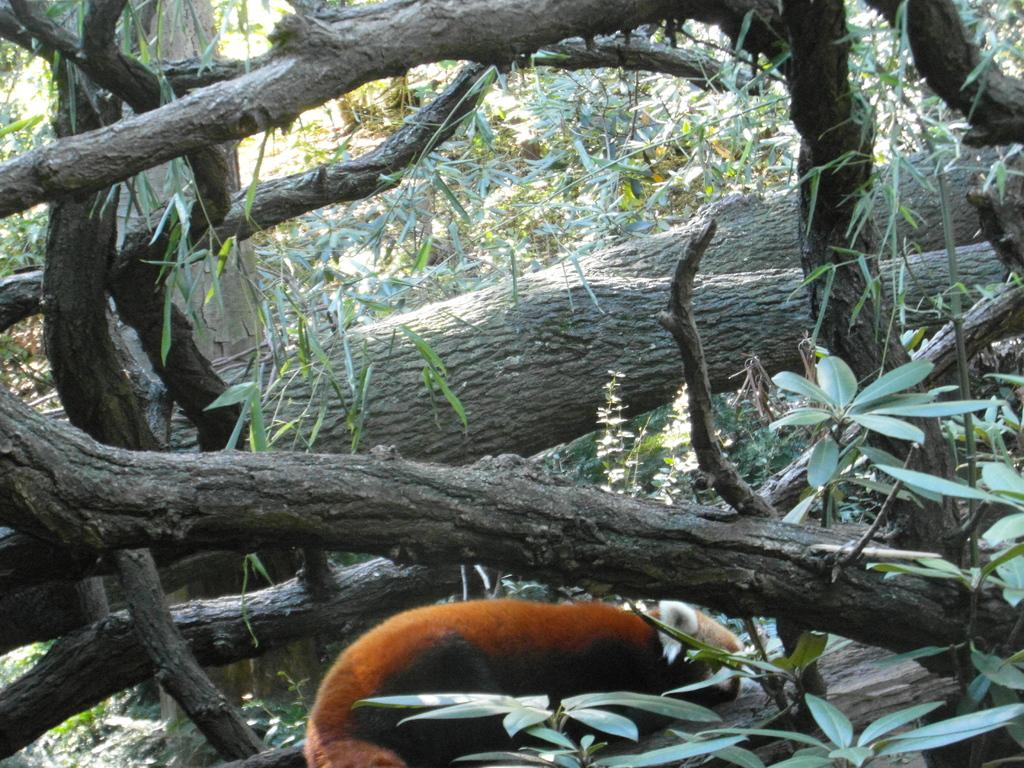What type of creature is in the image? There is an animal in the image. Where is the animal located? The animal is on a branch. What is the color of the animal? The animal is brown in color. What else can be seen in the image besides the animal? There are leaves and a tree in the image. How many teeth can be seen in the image? There are no teeth visible in the image, as it features an animal on a branch. 